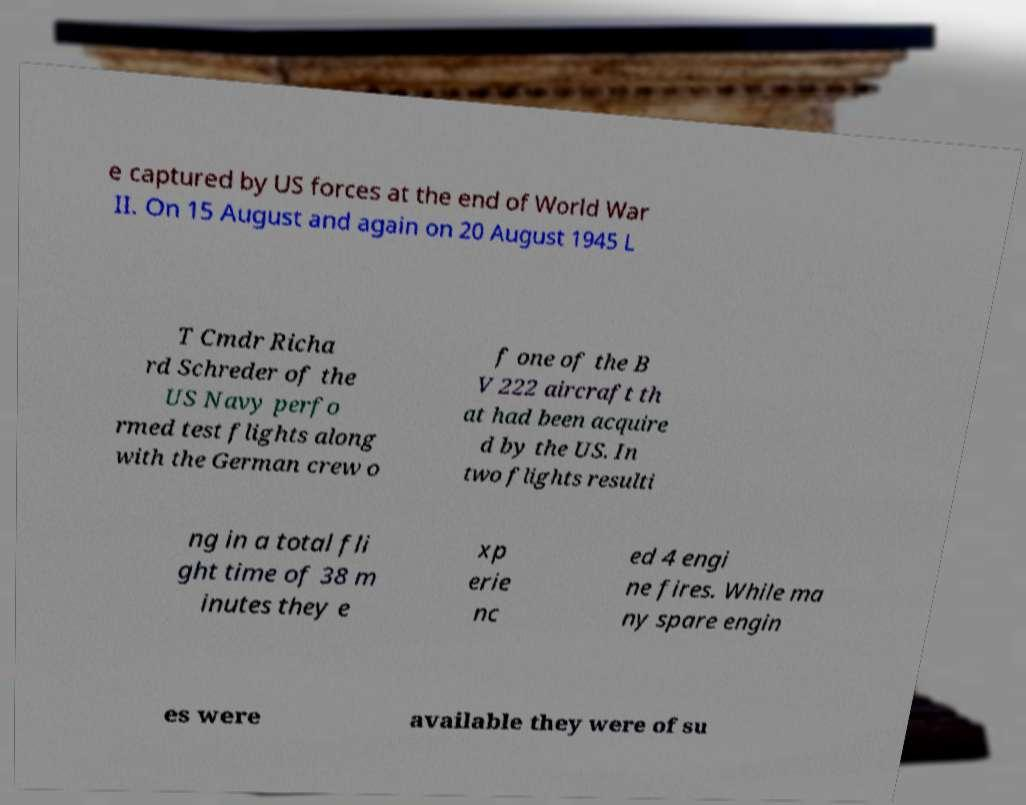Can you read and provide the text displayed in the image?This photo seems to have some interesting text. Can you extract and type it out for me? e captured by US forces at the end of World War II. On 15 August and again on 20 August 1945 L T Cmdr Richa rd Schreder of the US Navy perfo rmed test flights along with the German crew o f one of the B V 222 aircraft th at had been acquire d by the US. In two flights resulti ng in a total fli ght time of 38 m inutes they e xp erie nc ed 4 engi ne fires. While ma ny spare engin es were available they were of su 